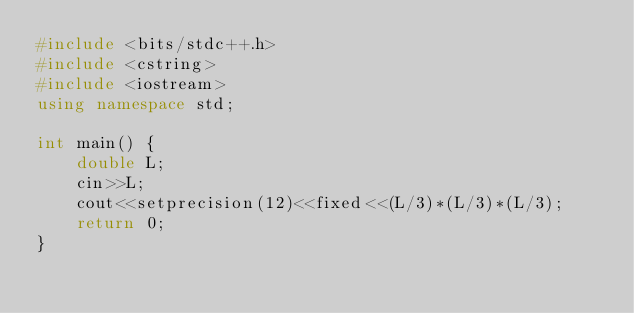Convert code to text. <code><loc_0><loc_0><loc_500><loc_500><_C++_>#include <bits/stdc++.h>
#include <cstring>
#include <iostream>
using namespace std;

int main() {
    double L;
    cin>>L;
    cout<<setprecision(12)<<fixed<<(L/3)*(L/3)*(L/3);
    return 0;
}</code> 